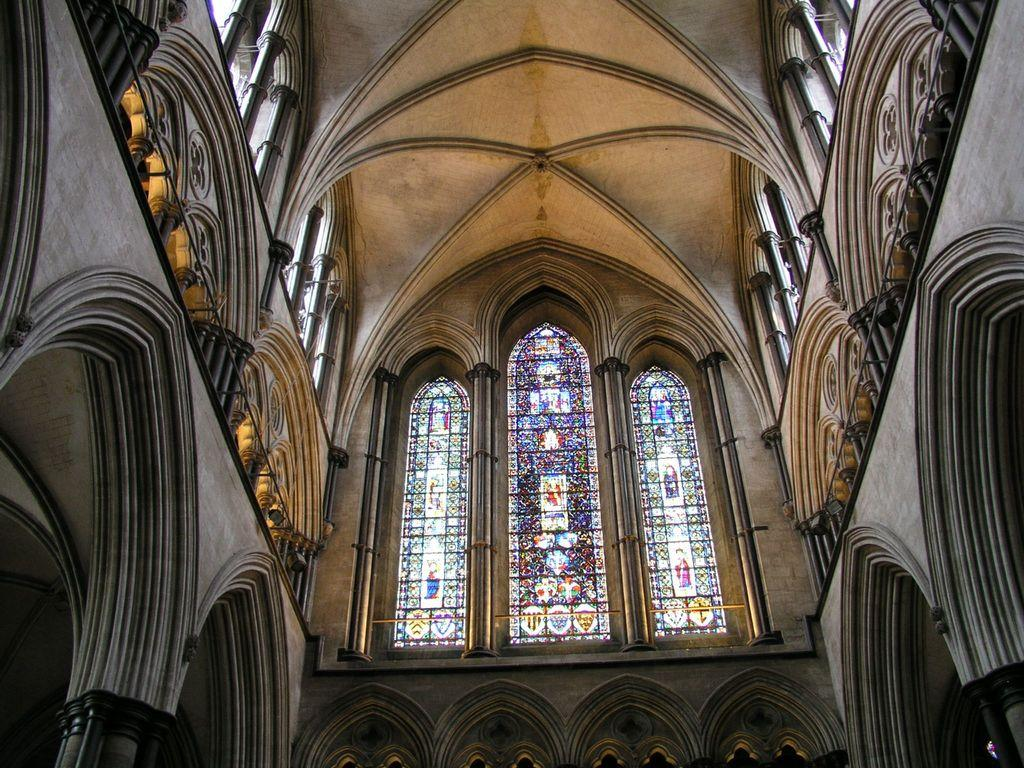What type of structure is shown in the image? The image shows an inner view of a building. What architectural features can be seen in the image? There are arches and pillars visible in the image. What part of the building's structure is visible in the image? The walls are visible in the image. What material is used for the windows in the image? There is glass in the image, which is used for the windows. What part of the building's exterior is visible in the image? The roof is visible in the image. Can you tell me how many dimes are scattered on the floor in the image? There are no dimes visible in the image; it shows an inner view of a building with architectural features and materials. Is there any indication of an earthquake happening in the image? There is no indication of an earthquake or any damage to the building in the image. 